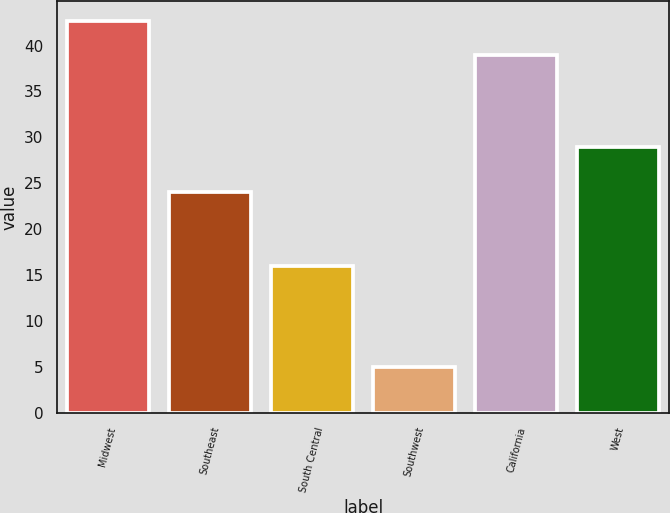Convert chart. <chart><loc_0><loc_0><loc_500><loc_500><bar_chart><fcel>Midwest<fcel>Southeast<fcel>South Central<fcel>Southwest<fcel>California<fcel>West<nl><fcel>42.7<fcel>24<fcel>16<fcel>5<fcel>39<fcel>29<nl></chart> 